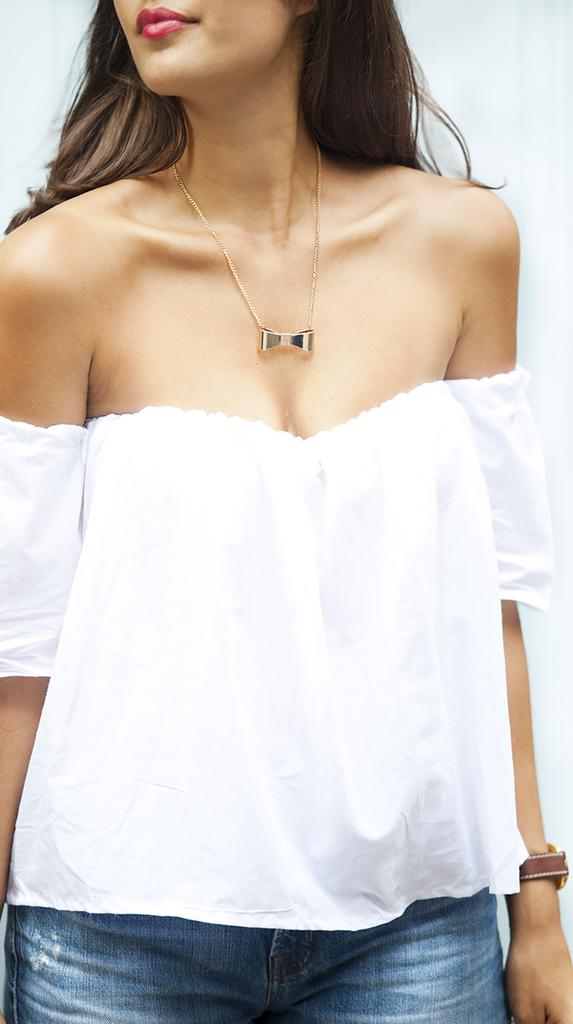Who is the main subject in the picture? There is a woman in the picture. What is the woman wearing on her upper body? The woman is wearing a white top. What type of pants is the woman wearing? The woman is wearing blue jeans. What accessory is the woman wearing around her neck? The woman has a necklace around her neck. What position is the woman in the picture? The woman is standing. What type of crate can be seen in the picture? There is no crate present in the picture; it features a woman wearing a white top, blue jeans, and a necklace while standing. 